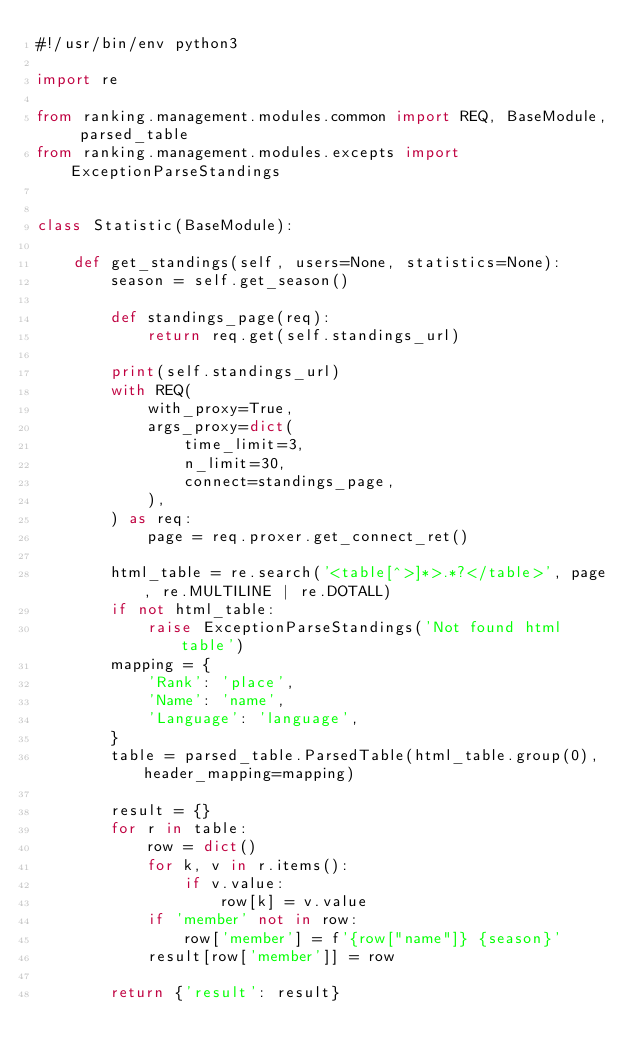<code> <loc_0><loc_0><loc_500><loc_500><_Python_>#!/usr/bin/env python3

import re

from ranking.management.modules.common import REQ, BaseModule, parsed_table
from ranking.management.modules.excepts import ExceptionParseStandings


class Statistic(BaseModule):

    def get_standings(self, users=None, statistics=None):
        season = self.get_season()

        def standings_page(req):
            return req.get(self.standings_url)

        print(self.standings_url)
        with REQ(
            with_proxy=True,
            args_proxy=dict(
                time_limit=3,
                n_limit=30,
                connect=standings_page,
            ),
        ) as req:
            page = req.proxer.get_connect_ret()

        html_table = re.search('<table[^>]*>.*?</table>', page, re.MULTILINE | re.DOTALL)
        if not html_table:
            raise ExceptionParseStandings('Not found html table')
        mapping = {
            'Rank': 'place',
            'Name': 'name',
            'Language': 'language',
        }
        table = parsed_table.ParsedTable(html_table.group(0), header_mapping=mapping)

        result = {}
        for r in table:
            row = dict()
            for k, v in r.items():
                if v.value:
                    row[k] = v.value
            if 'member' not in row:
                row['member'] = f'{row["name"]} {season}'
            result[row['member']] = row

        return {'result': result}
</code> 